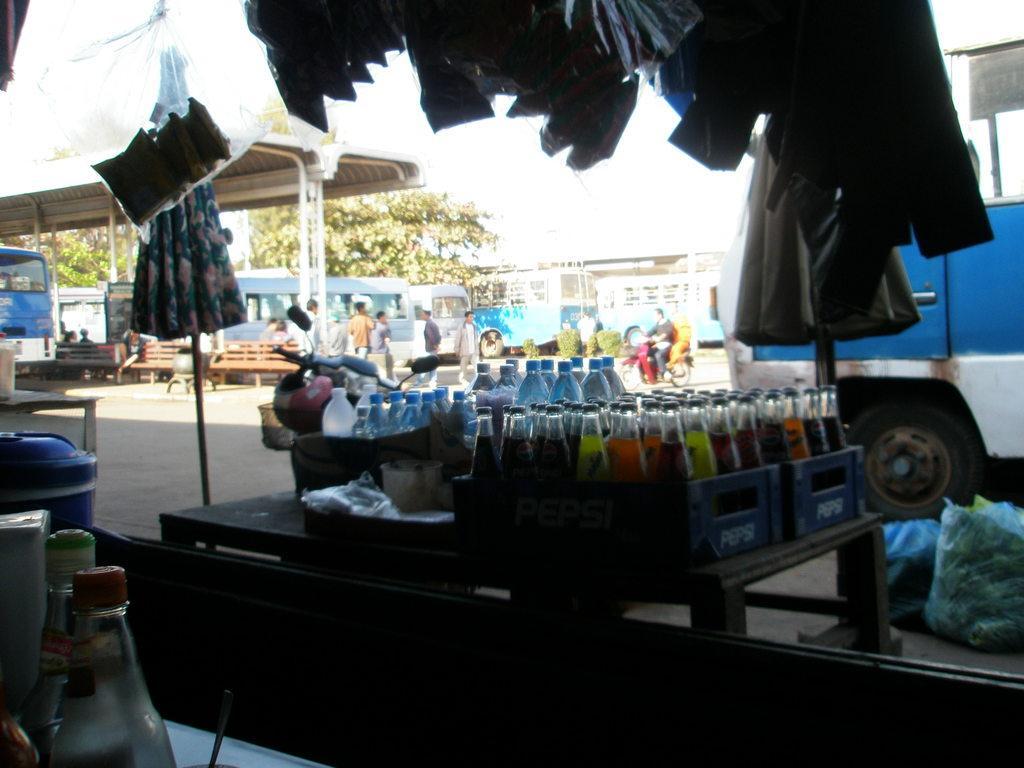Can you describe this image briefly? In this image there are some cool drink glasses in middle of this image and there are some bottles in blue color left side to this cool drink glasses. there are some buses in middle of this image and there is a tree behind these buses and there are some clothes at top of this image and there is a vehicle at right side of this image. there are some bottles at top left corner of this image and there is a table at left side of this image and one bottle kept on this table. 